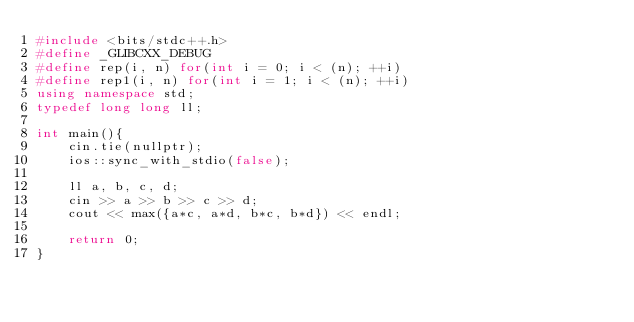<code> <loc_0><loc_0><loc_500><loc_500><_C++_>#include <bits/stdc++.h>
#define _GLIBCXX_DEBUG
#define rep(i, n) for(int i = 0; i < (n); ++i)
#define rep1(i, n) for(int i = 1; i < (n); ++i)
using namespace std;
typedef long long ll;

int main(){
    cin.tie(nullptr);
    ios::sync_with_stdio(false);

    ll a, b, c, d;
    cin >> a >> b >> c >> d;
    cout << max({a*c, a*d, b*c, b*d}) << endl;

    return 0;
}</code> 